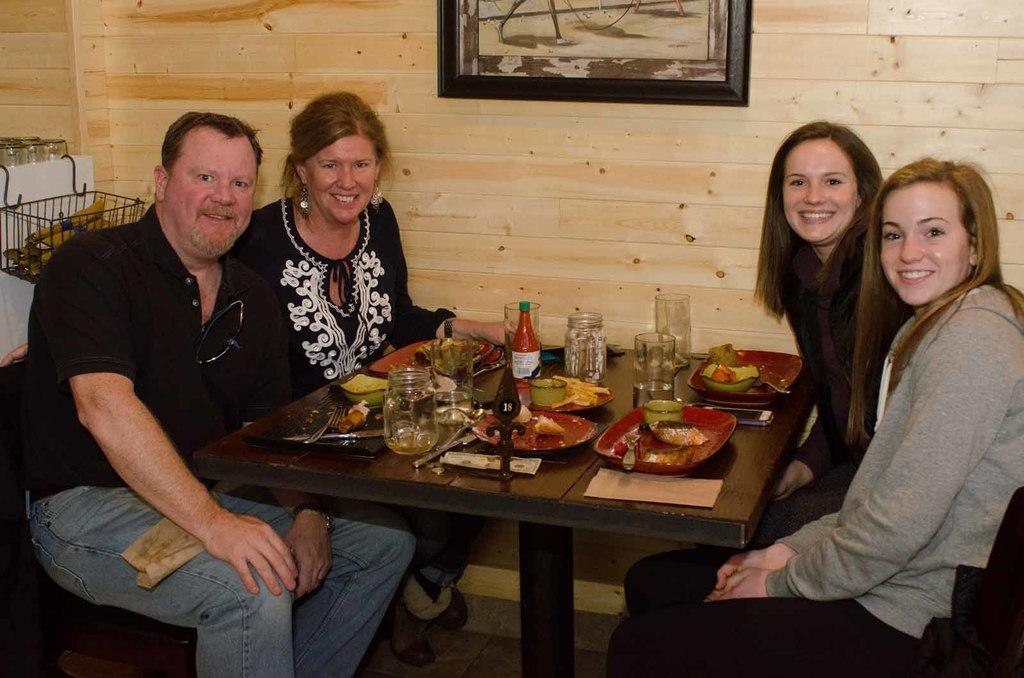What are the people in the image doing? The people in the image are sitting on chairs. What is present in the image besides the people? There is a table in the image. What can be found on the table? There are food items, a jar, ketchup bottles, and glasses on the table. How many jellyfish are swimming in the glasses on the table? There are no jellyfish present in the image; the glasses contain liquid, likely water or a beverage. 